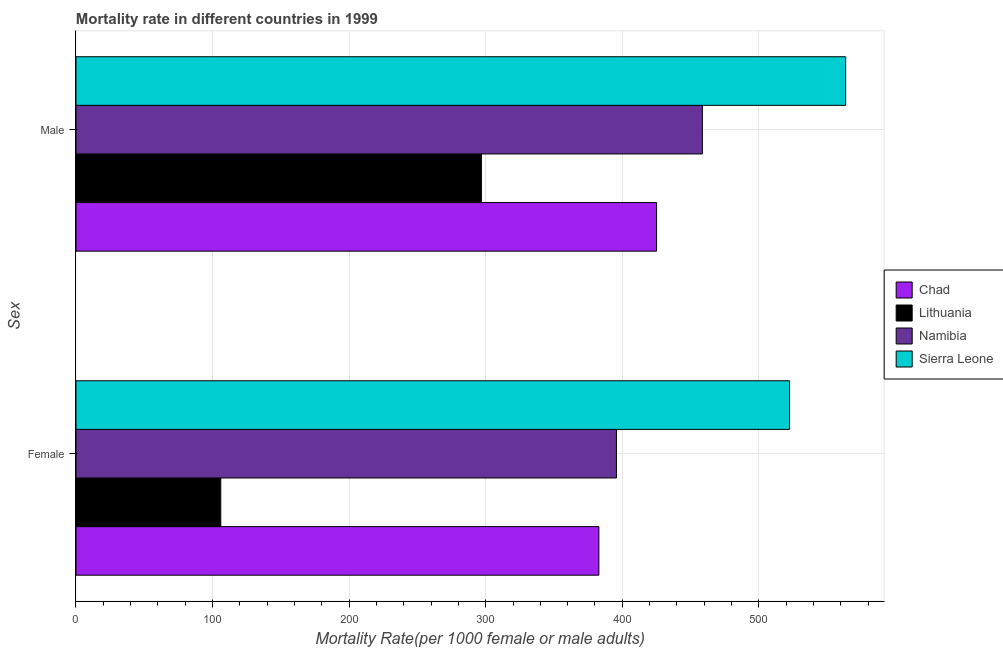How many different coloured bars are there?
Provide a succinct answer. 4. Are the number of bars per tick equal to the number of legend labels?
Offer a very short reply. Yes. Are the number of bars on each tick of the Y-axis equal?
Your response must be concise. Yes. How many bars are there on the 1st tick from the top?
Offer a very short reply. 4. How many bars are there on the 1st tick from the bottom?
Make the answer very short. 4. What is the male mortality rate in Lithuania?
Keep it short and to the point. 296.83. Across all countries, what is the maximum female mortality rate?
Ensure brevity in your answer.  522.49. Across all countries, what is the minimum male mortality rate?
Provide a succinct answer. 296.83. In which country was the male mortality rate maximum?
Your answer should be very brief. Sierra Leone. In which country was the female mortality rate minimum?
Ensure brevity in your answer.  Lithuania. What is the total male mortality rate in the graph?
Offer a terse response. 1744.09. What is the difference between the male mortality rate in Lithuania and that in Namibia?
Keep it short and to the point. -161.8. What is the difference between the male mortality rate in Lithuania and the female mortality rate in Namibia?
Your answer should be compact. -98.88. What is the average female mortality rate per country?
Ensure brevity in your answer.  351.76. What is the difference between the male mortality rate and female mortality rate in Sierra Leone?
Your answer should be very brief. 41.07. What is the ratio of the female mortality rate in Chad to that in Lithuania?
Offer a terse response. 3.61. Is the female mortality rate in Namibia less than that in Lithuania?
Ensure brevity in your answer.  No. What does the 4th bar from the top in Male represents?
Keep it short and to the point. Chad. What does the 1st bar from the bottom in Female represents?
Your answer should be compact. Chad. How many bars are there?
Keep it short and to the point. 8. How many countries are there in the graph?
Give a very brief answer. 4. What is the difference between two consecutive major ticks on the X-axis?
Your response must be concise. 100. Does the graph contain any zero values?
Ensure brevity in your answer.  No. Does the graph contain grids?
Provide a short and direct response. Yes. How many legend labels are there?
Ensure brevity in your answer.  4. How are the legend labels stacked?
Provide a succinct answer. Vertical. What is the title of the graph?
Keep it short and to the point. Mortality rate in different countries in 1999. Does "Paraguay" appear as one of the legend labels in the graph?
Offer a very short reply. No. What is the label or title of the X-axis?
Your answer should be very brief. Mortality Rate(per 1000 female or male adults). What is the label or title of the Y-axis?
Give a very brief answer. Sex. What is the Mortality Rate(per 1000 female or male adults) in Chad in Female?
Your answer should be compact. 382.85. What is the Mortality Rate(per 1000 female or male adults) of Lithuania in Female?
Provide a short and direct response. 106. What is the Mortality Rate(per 1000 female or male adults) in Namibia in Female?
Give a very brief answer. 395.7. What is the Mortality Rate(per 1000 female or male adults) in Sierra Leone in Female?
Provide a short and direct response. 522.49. What is the Mortality Rate(per 1000 female or male adults) of Chad in Male?
Provide a short and direct response. 425.08. What is the Mortality Rate(per 1000 female or male adults) of Lithuania in Male?
Your answer should be compact. 296.83. What is the Mortality Rate(per 1000 female or male adults) of Namibia in Male?
Offer a very short reply. 458.63. What is the Mortality Rate(per 1000 female or male adults) in Sierra Leone in Male?
Give a very brief answer. 563.55. Across all Sex, what is the maximum Mortality Rate(per 1000 female or male adults) of Chad?
Your answer should be very brief. 425.08. Across all Sex, what is the maximum Mortality Rate(per 1000 female or male adults) of Lithuania?
Your answer should be very brief. 296.83. Across all Sex, what is the maximum Mortality Rate(per 1000 female or male adults) in Namibia?
Offer a very short reply. 458.63. Across all Sex, what is the maximum Mortality Rate(per 1000 female or male adults) in Sierra Leone?
Ensure brevity in your answer.  563.55. Across all Sex, what is the minimum Mortality Rate(per 1000 female or male adults) in Chad?
Keep it short and to the point. 382.85. Across all Sex, what is the minimum Mortality Rate(per 1000 female or male adults) in Lithuania?
Make the answer very short. 106. Across all Sex, what is the minimum Mortality Rate(per 1000 female or male adults) in Namibia?
Your response must be concise. 395.7. Across all Sex, what is the minimum Mortality Rate(per 1000 female or male adults) in Sierra Leone?
Keep it short and to the point. 522.49. What is the total Mortality Rate(per 1000 female or male adults) of Chad in the graph?
Your answer should be very brief. 807.93. What is the total Mortality Rate(per 1000 female or male adults) of Lithuania in the graph?
Give a very brief answer. 402.83. What is the total Mortality Rate(per 1000 female or male adults) in Namibia in the graph?
Give a very brief answer. 854.33. What is the total Mortality Rate(per 1000 female or male adults) in Sierra Leone in the graph?
Ensure brevity in your answer.  1086.04. What is the difference between the Mortality Rate(per 1000 female or male adults) in Chad in Female and that in Male?
Provide a succinct answer. -42.23. What is the difference between the Mortality Rate(per 1000 female or male adults) of Lithuania in Female and that in Male?
Keep it short and to the point. -190.82. What is the difference between the Mortality Rate(per 1000 female or male adults) of Namibia in Female and that in Male?
Offer a very short reply. -62.93. What is the difference between the Mortality Rate(per 1000 female or male adults) in Sierra Leone in Female and that in Male?
Offer a terse response. -41.07. What is the difference between the Mortality Rate(per 1000 female or male adults) of Chad in Female and the Mortality Rate(per 1000 female or male adults) of Lithuania in Male?
Provide a short and direct response. 86.02. What is the difference between the Mortality Rate(per 1000 female or male adults) in Chad in Female and the Mortality Rate(per 1000 female or male adults) in Namibia in Male?
Ensure brevity in your answer.  -75.78. What is the difference between the Mortality Rate(per 1000 female or male adults) of Chad in Female and the Mortality Rate(per 1000 female or male adults) of Sierra Leone in Male?
Give a very brief answer. -180.7. What is the difference between the Mortality Rate(per 1000 female or male adults) of Lithuania in Female and the Mortality Rate(per 1000 female or male adults) of Namibia in Male?
Your response must be concise. -352.63. What is the difference between the Mortality Rate(per 1000 female or male adults) of Lithuania in Female and the Mortality Rate(per 1000 female or male adults) of Sierra Leone in Male?
Make the answer very short. -457.55. What is the difference between the Mortality Rate(per 1000 female or male adults) of Namibia in Female and the Mortality Rate(per 1000 female or male adults) of Sierra Leone in Male?
Keep it short and to the point. -167.85. What is the average Mortality Rate(per 1000 female or male adults) in Chad per Sex?
Offer a terse response. 403.97. What is the average Mortality Rate(per 1000 female or male adults) in Lithuania per Sex?
Your answer should be compact. 201.42. What is the average Mortality Rate(per 1000 female or male adults) of Namibia per Sex?
Your answer should be compact. 427.17. What is the average Mortality Rate(per 1000 female or male adults) of Sierra Leone per Sex?
Your response must be concise. 543.02. What is the difference between the Mortality Rate(per 1000 female or male adults) of Chad and Mortality Rate(per 1000 female or male adults) of Lithuania in Female?
Give a very brief answer. 276.84. What is the difference between the Mortality Rate(per 1000 female or male adults) in Chad and Mortality Rate(per 1000 female or male adults) in Namibia in Female?
Your answer should be compact. -12.85. What is the difference between the Mortality Rate(per 1000 female or male adults) in Chad and Mortality Rate(per 1000 female or male adults) in Sierra Leone in Female?
Keep it short and to the point. -139.64. What is the difference between the Mortality Rate(per 1000 female or male adults) of Lithuania and Mortality Rate(per 1000 female or male adults) of Namibia in Female?
Offer a very short reply. -289.7. What is the difference between the Mortality Rate(per 1000 female or male adults) of Lithuania and Mortality Rate(per 1000 female or male adults) of Sierra Leone in Female?
Provide a short and direct response. -416.48. What is the difference between the Mortality Rate(per 1000 female or male adults) of Namibia and Mortality Rate(per 1000 female or male adults) of Sierra Leone in Female?
Ensure brevity in your answer.  -126.78. What is the difference between the Mortality Rate(per 1000 female or male adults) of Chad and Mortality Rate(per 1000 female or male adults) of Lithuania in Male?
Make the answer very short. 128.26. What is the difference between the Mortality Rate(per 1000 female or male adults) of Chad and Mortality Rate(per 1000 female or male adults) of Namibia in Male?
Your answer should be compact. -33.55. What is the difference between the Mortality Rate(per 1000 female or male adults) of Chad and Mortality Rate(per 1000 female or male adults) of Sierra Leone in Male?
Ensure brevity in your answer.  -138.47. What is the difference between the Mortality Rate(per 1000 female or male adults) of Lithuania and Mortality Rate(per 1000 female or male adults) of Namibia in Male?
Your answer should be very brief. -161.81. What is the difference between the Mortality Rate(per 1000 female or male adults) in Lithuania and Mortality Rate(per 1000 female or male adults) in Sierra Leone in Male?
Offer a very short reply. -266.73. What is the difference between the Mortality Rate(per 1000 female or male adults) of Namibia and Mortality Rate(per 1000 female or male adults) of Sierra Leone in Male?
Offer a very short reply. -104.92. What is the ratio of the Mortality Rate(per 1000 female or male adults) of Chad in Female to that in Male?
Provide a short and direct response. 0.9. What is the ratio of the Mortality Rate(per 1000 female or male adults) in Lithuania in Female to that in Male?
Your answer should be compact. 0.36. What is the ratio of the Mortality Rate(per 1000 female or male adults) in Namibia in Female to that in Male?
Your answer should be compact. 0.86. What is the ratio of the Mortality Rate(per 1000 female or male adults) in Sierra Leone in Female to that in Male?
Keep it short and to the point. 0.93. What is the difference between the highest and the second highest Mortality Rate(per 1000 female or male adults) in Chad?
Your response must be concise. 42.23. What is the difference between the highest and the second highest Mortality Rate(per 1000 female or male adults) in Lithuania?
Ensure brevity in your answer.  190.82. What is the difference between the highest and the second highest Mortality Rate(per 1000 female or male adults) in Namibia?
Provide a succinct answer. 62.93. What is the difference between the highest and the second highest Mortality Rate(per 1000 female or male adults) in Sierra Leone?
Provide a short and direct response. 41.07. What is the difference between the highest and the lowest Mortality Rate(per 1000 female or male adults) of Chad?
Make the answer very short. 42.23. What is the difference between the highest and the lowest Mortality Rate(per 1000 female or male adults) of Lithuania?
Your answer should be compact. 190.82. What is the difference between the highest and the lowest Mortality Rate(per 1000 female or male adults) in Namibia?
Your response must be concise. 62.93. What is the difference between the highest and the lowest Mortality Rate(per 1000 female or male adults) of Sierra Leone?
Keep it short and to the point. 41.07. 